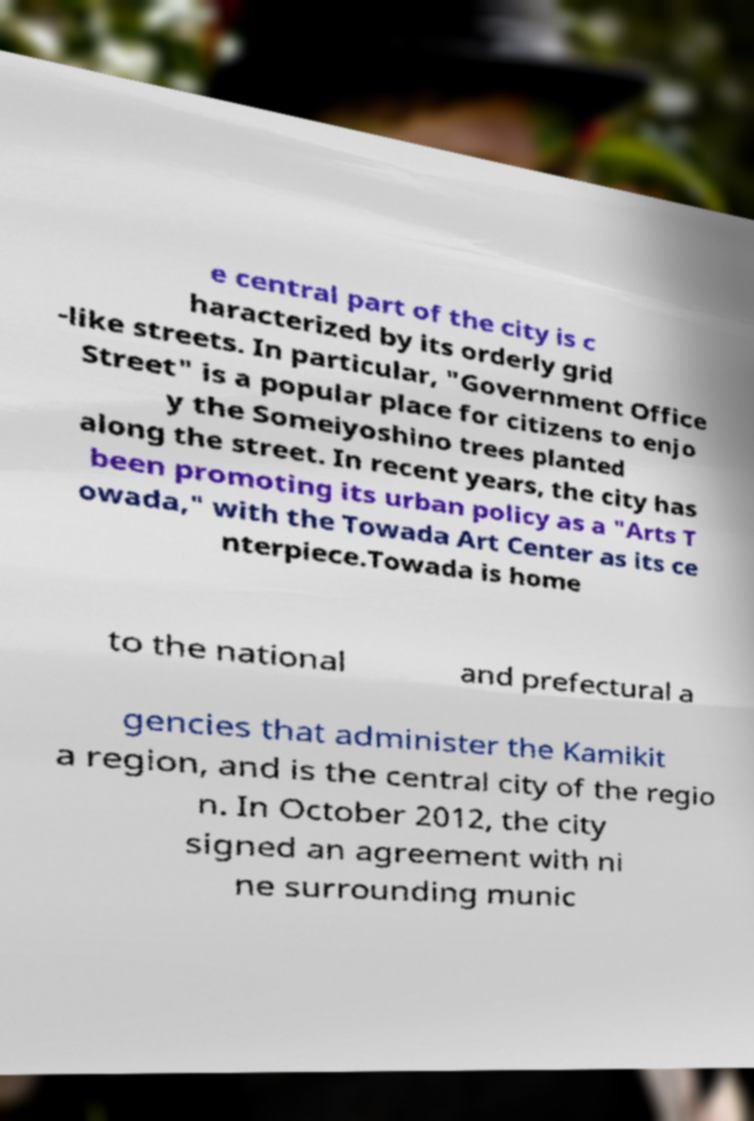Could you extract and type out the text from this image? e central part of the city is c haracterized by its orderly grid -like streets. In particular, "Government Office Street" is a popular place for citizens to enjo y the Someiyoshino trees planted along the street. In recent years, the city has been promoting its urban policy as a "Arts T owada," with the Towada Art Center as its ce nterpiece.Towada is home to the national and prefectural a gencies that administer the Kamikit a region, and is the central city of the regio n. In October 2012, the city signed an agreement with ni ne surrounding munic 